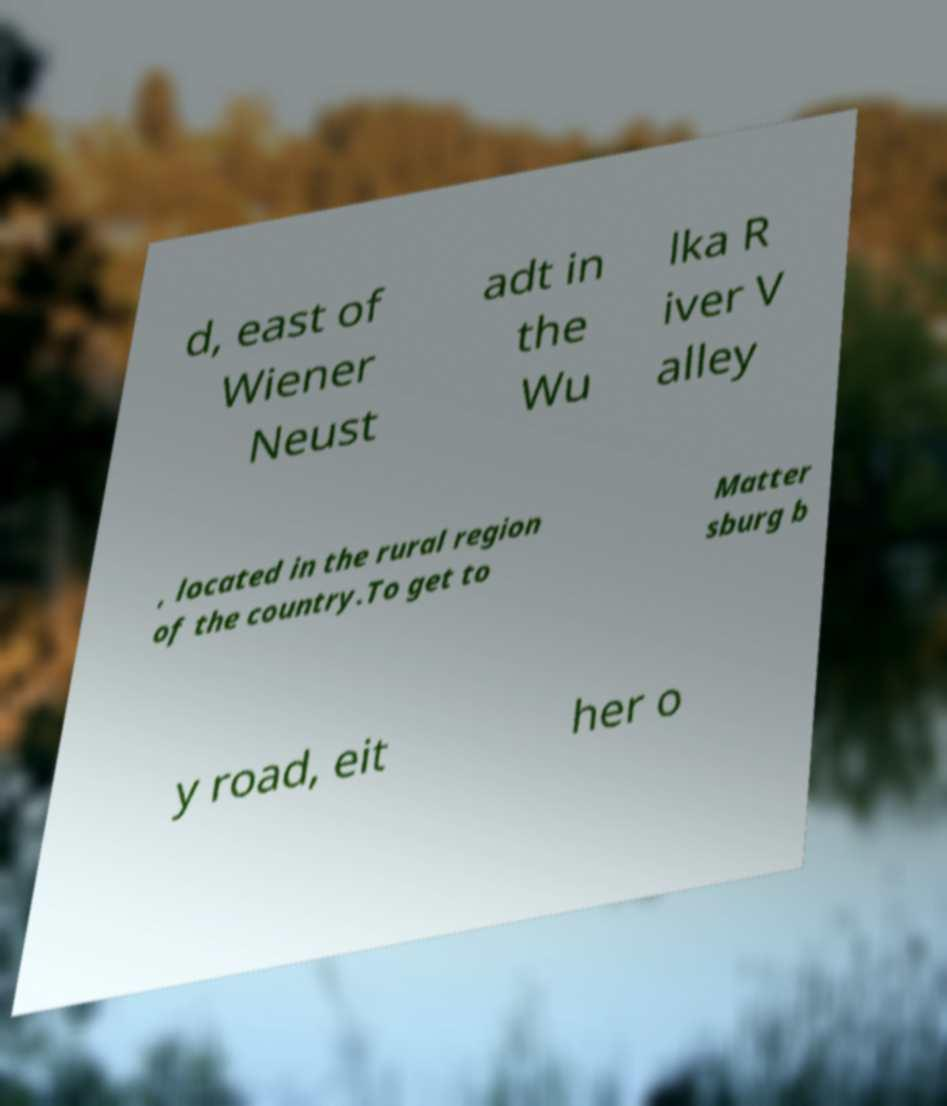Please identify and transcribe the text found in this image. d, east of Wiener Neust adt in the Wu lka R iver V alley , located in the rural region of the country.To get to Matter sburg b y road, eit her o 